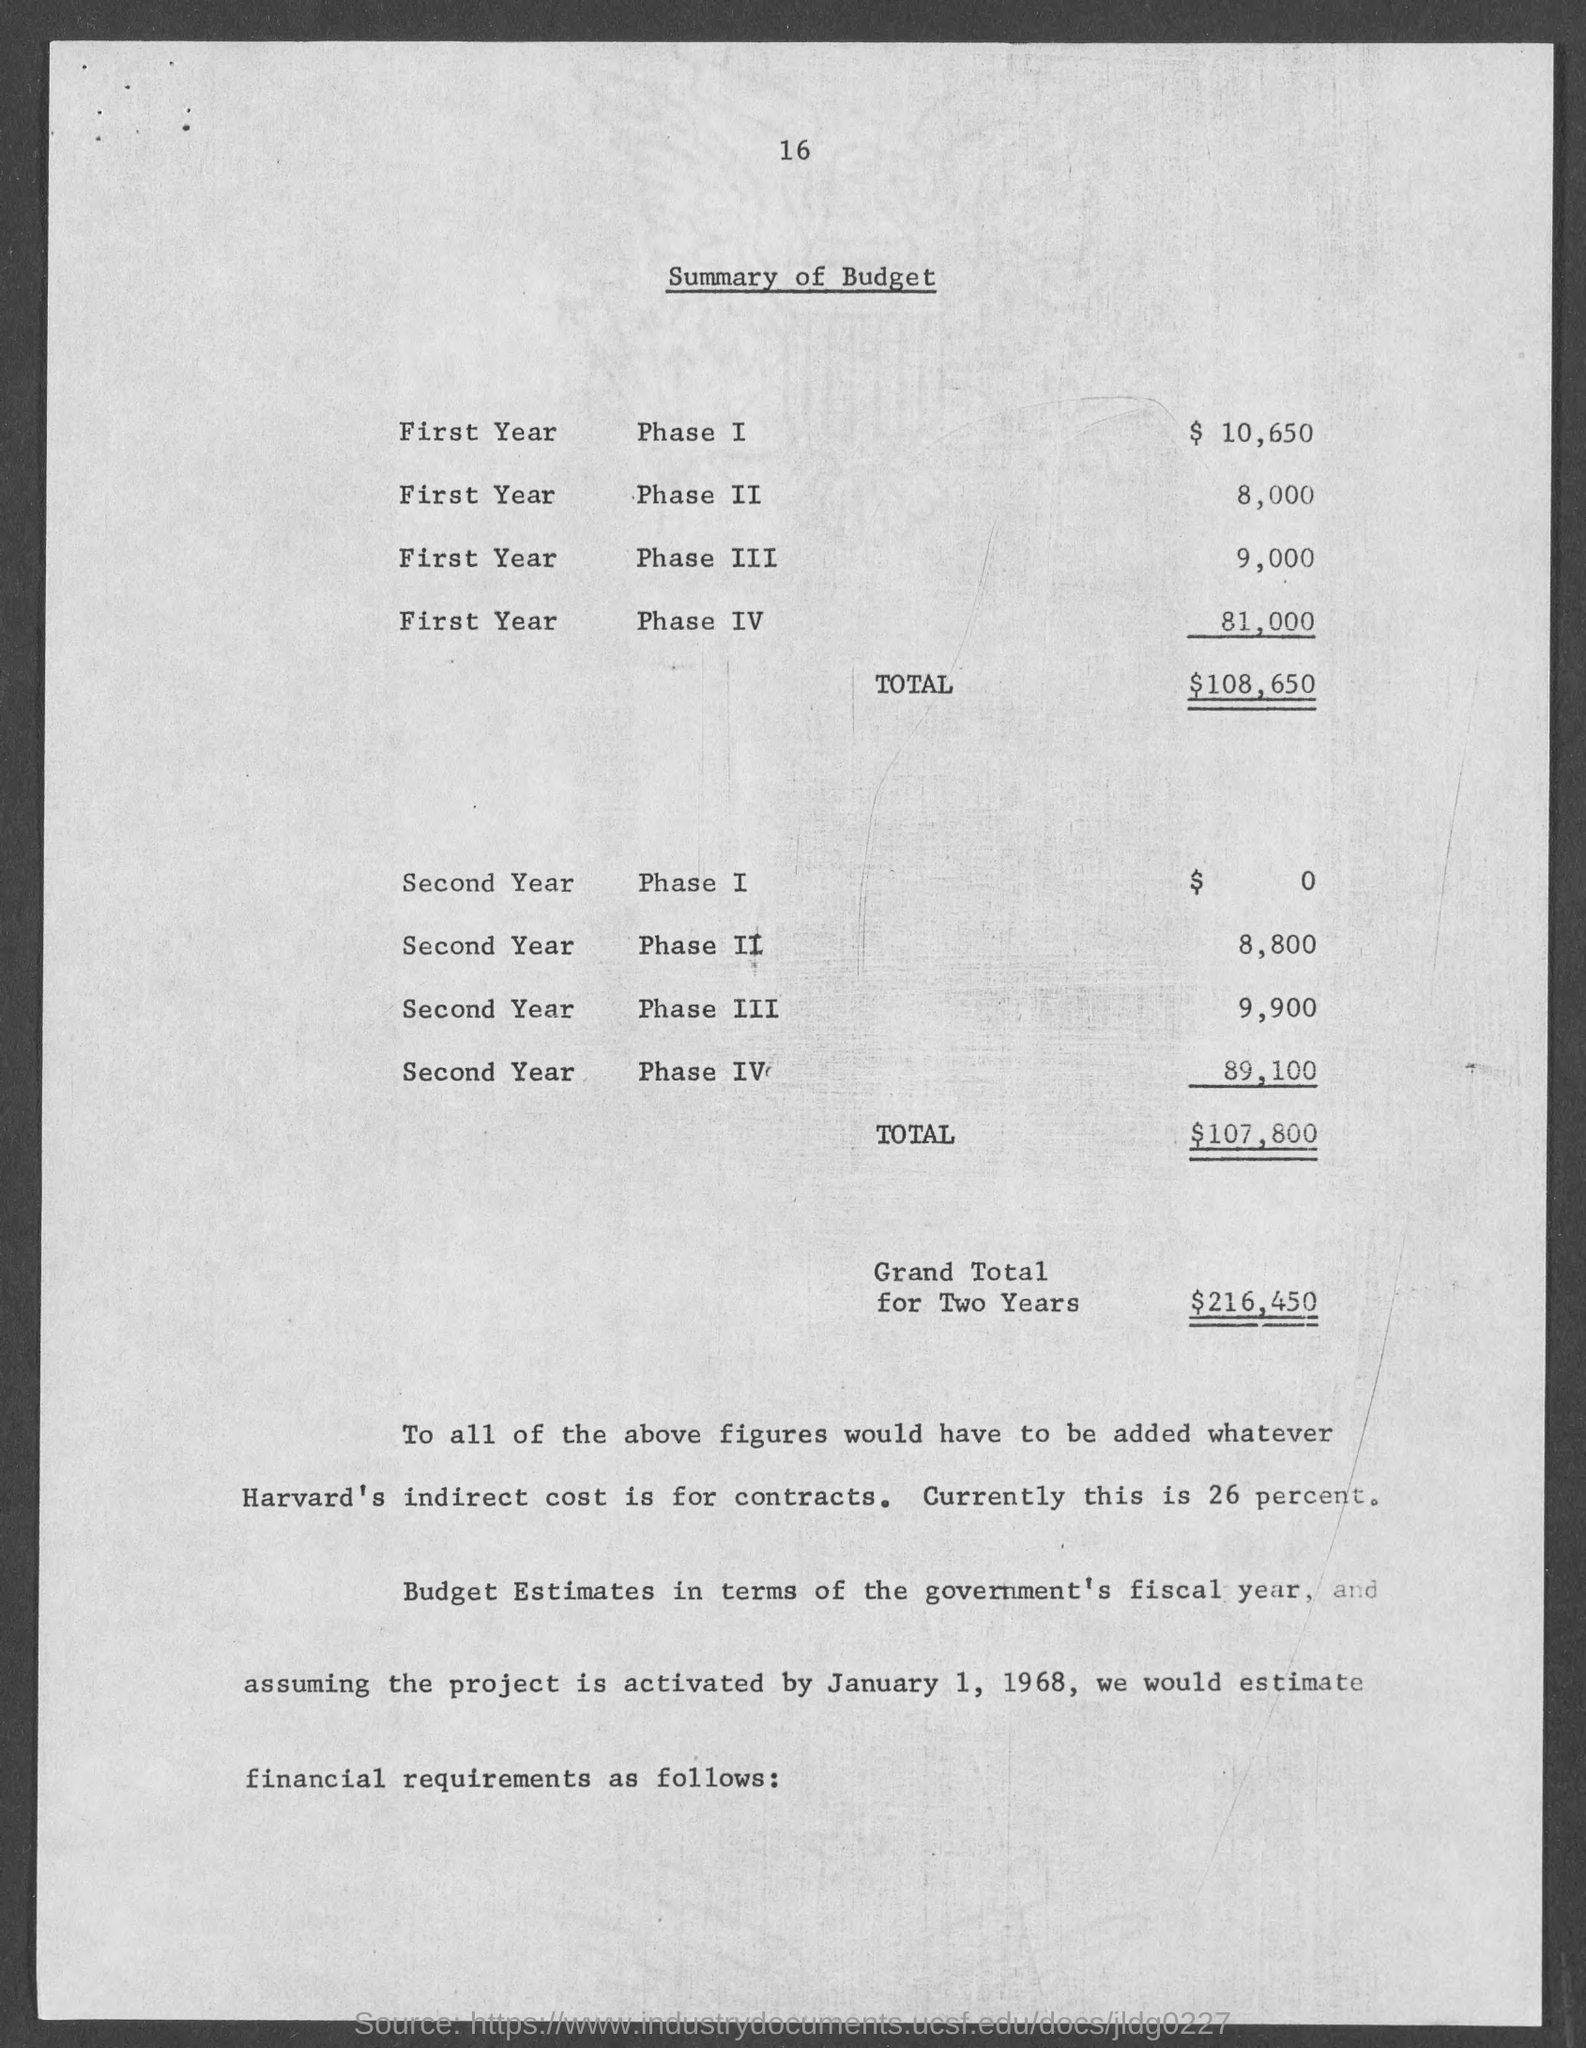What is the amount of budget in phase 1 in first year ?
Give a very brief answer. $ 10,650. What is the amount of budget in phase 2 in first year ?
Provide a succinct answer. 8,000. What is the amount of total budget during first year ?
Keep it short and to the point. $ 108,650. What is the amount of budget given in phase 1 in second year ?
Keep it short and to the point. 0. What is the amount of budget given in phase 2 of second year ?
Provide a succinct answer. 8,800. What is the amount of total budget in second year ?
Keep it short and to the point. $107,800. What is the amount of grand total for two years ?
Ensure brevity in your answer.  $216,450. What is the amount of budget given in phase 3 in second year ?
Give a very brief answer. 9,900. What is the amount of budget given in phase 3 in first year  ?
Keep it short and to the point. 9,000. What is the amount of budget given in phase 4 in first year ?
Provide a succinct answer. 81,000. 